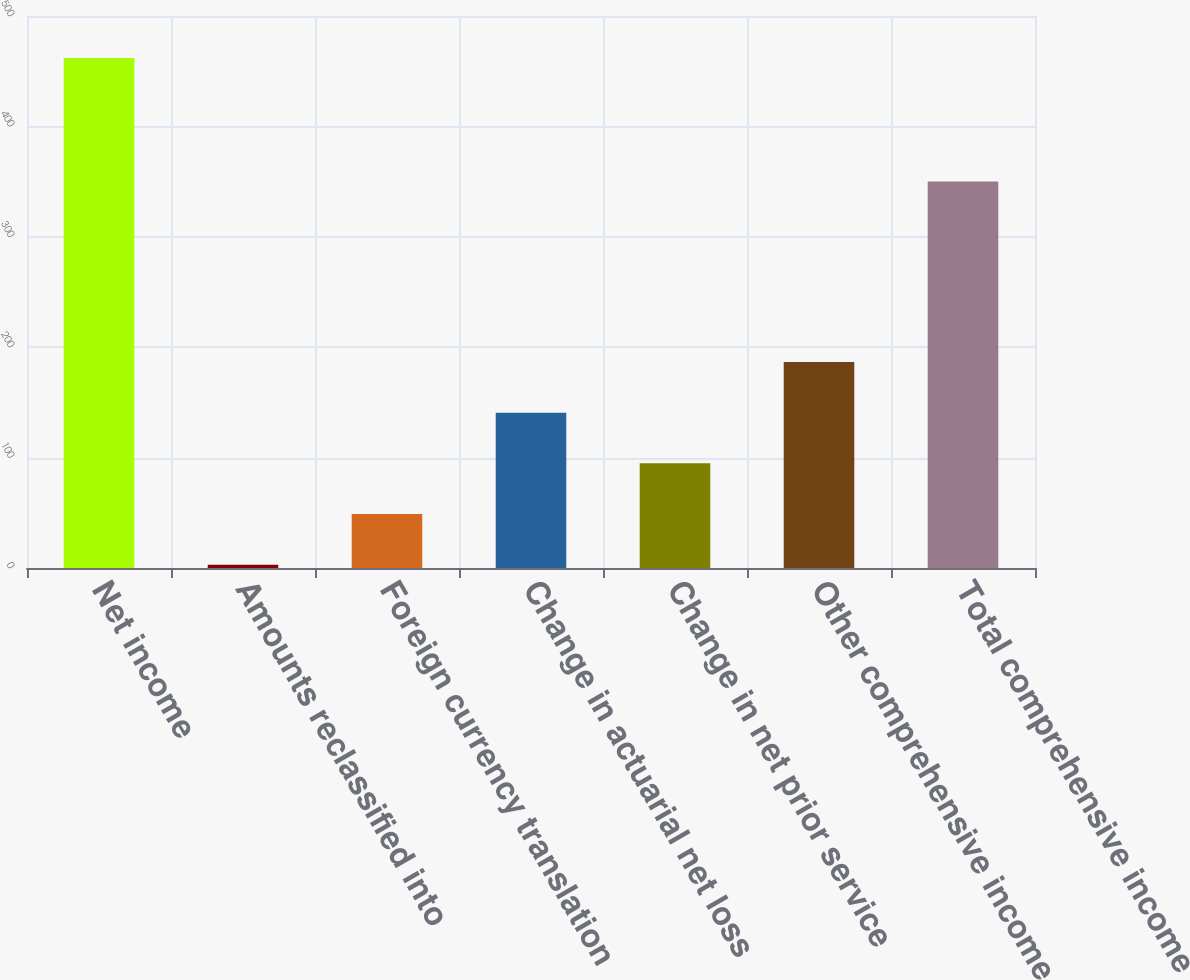Convert chart. <chart><loc_0><loc_0><loc_500><loc_500><bar_chart><fcel>Net income<fcel>Amounts reclassified into<fcel>Foreign currency translation<fcel>Change in actuarial net loss<fcel>Change in net prior service<fcel>Other comprehensive income<fcel>Total comprehensive income<nl><fcel>462<fcel>3<fcel>48.9<fcel>140.7<fcel>94.8<fcel>186.6<fcel>350<nl></chart> 